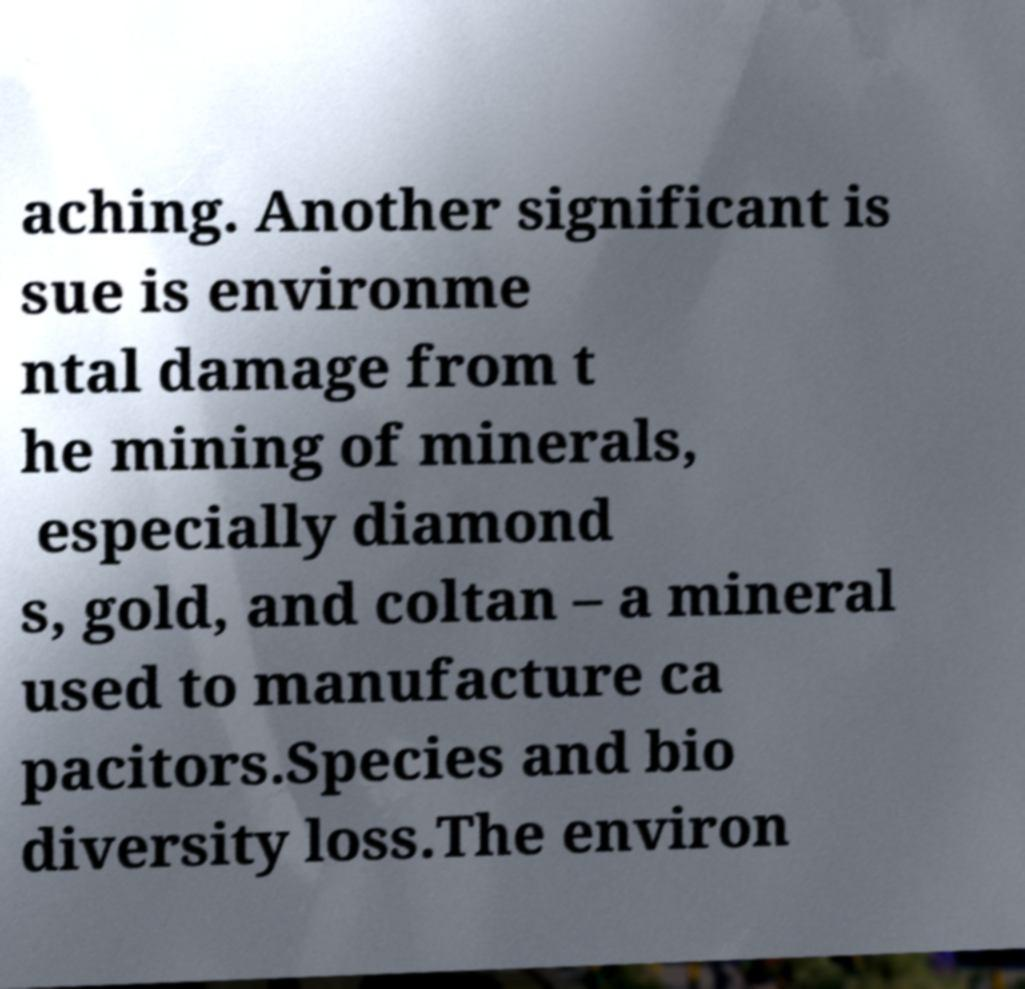Can you read and provide the text displayed in the image?This photo seems to have some interesting text. Can you extract and type it out for me? aching. Another significant is sue is environme ntal damage from t he mining of minerals, especially diamond s, gold, and coltan – a mineral used to manufacture ca pacitors.Species and bio diversity loss.The environ 